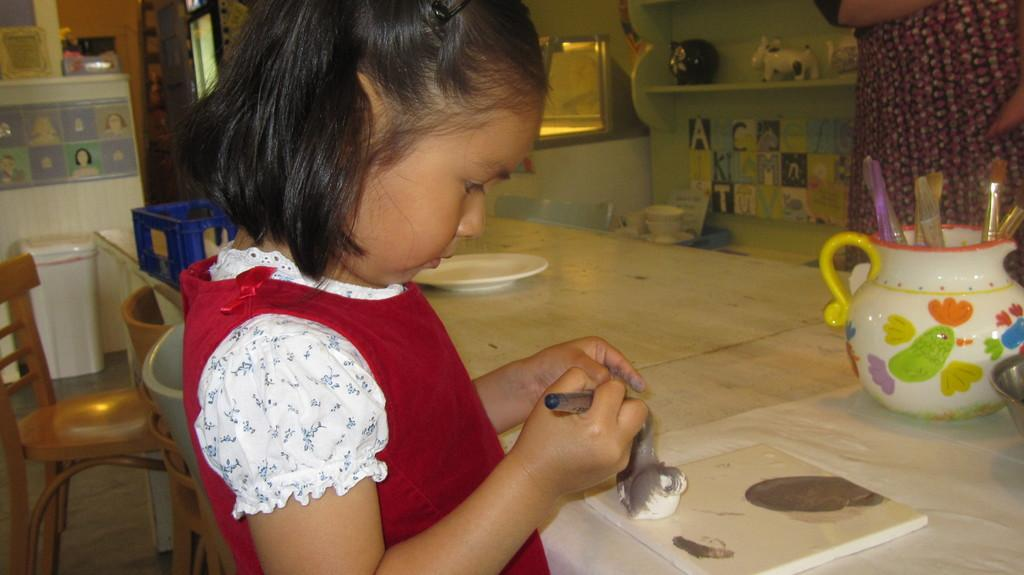Who is the main subject in the image? There is a girl in the image. What is the girl doing in the image? The girl is standing in the image. What is the girl holding in her right hand? The girl is holding an object in her right hand. What is on the table in front of the girl? There is a pot and plates on the table in front of the girl. What type of coat is the girl wearing in the image? There is no coat visible in the image; the girl is not wearing any outerwear. What kind of vessel is the girl holding in her right hand? The girl is not holding a vessel in her right hand; she is holding an unspecified object. 